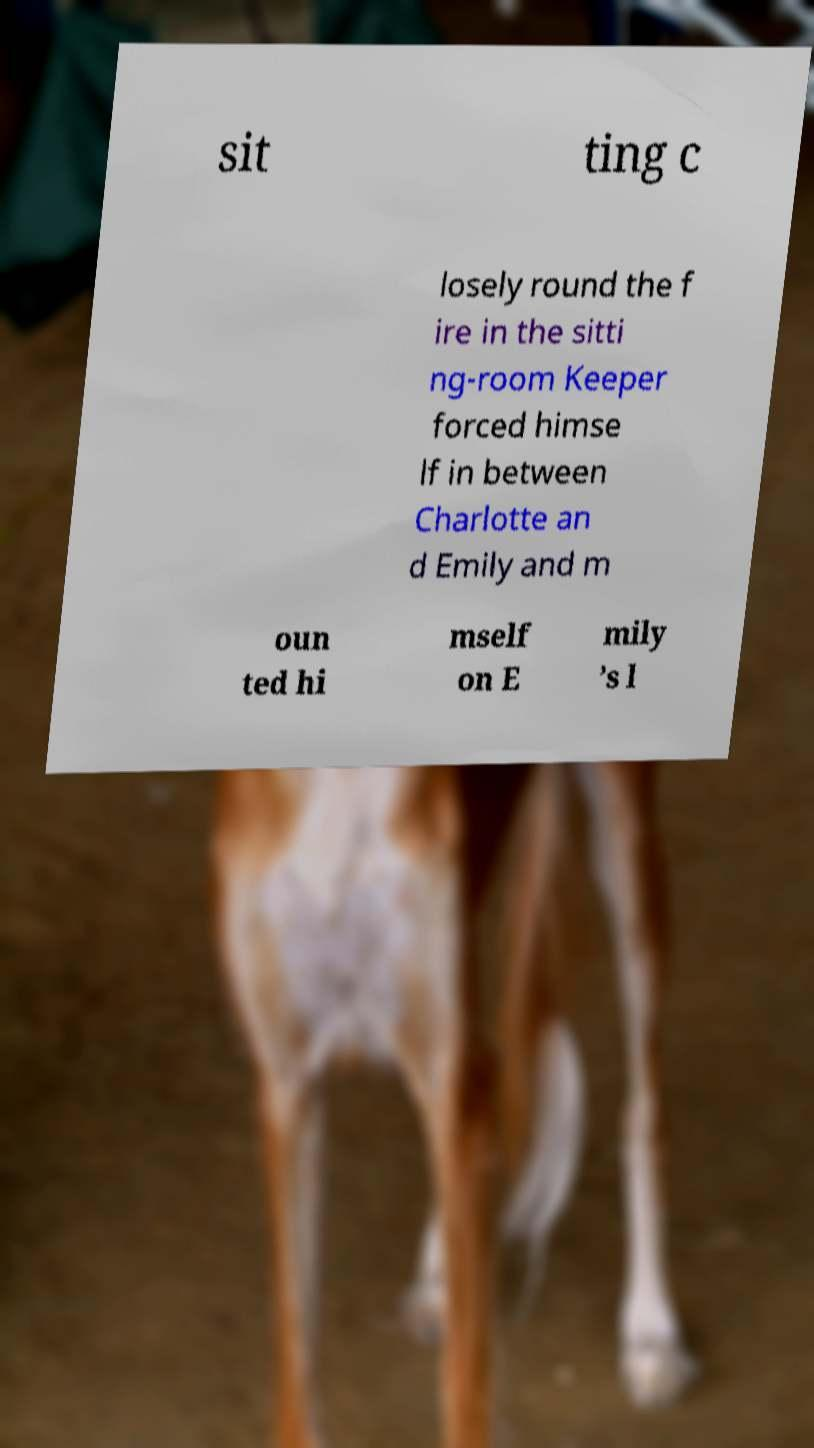What messages or text are displayed in this image? I need them in a readable, typed format. sit ting c losely round the f ire in the sitti ng-room Keeper forced himse lf in between Charlotte an d Emily and m oun ted hi mself on E mily ’s l 